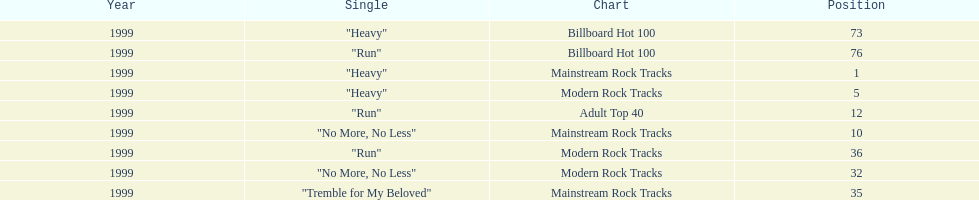How many singles from "dosage" appeared on the modern rock tracks charts? 3. 